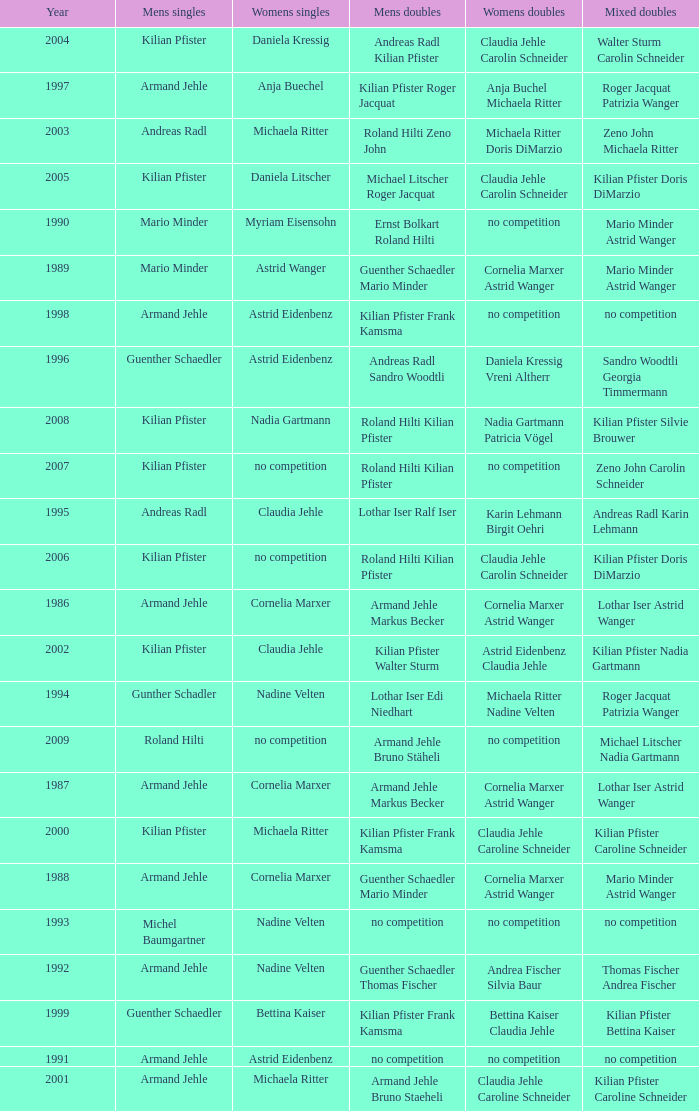In the year 2006, the womens singles had no competition and the mens doubles were roland hilti kilian pfister, what were the womens doubles Claudia Jehle Carolin Schneider. Could you parse the entire table? {'header': ['Year', 'Mens singles', 'Womens singles', 'Mens doubles', 'Womens doubles', 'Mixed doubles'], 'rows': [['2004', 'Kilian Pfister', 'Daniela Kressig', 'Andreas Radl Kilian Pfister', 'Claudia Jehle Carolin Schneider', 'Walter Sturm Carolin Schneider'], ['1997', 'Armand Jehle', 'Anja Buechel', 'Kilian Pfister Roger Jacquat', 'Anja Buchel Michaela Ritter', 'Roger Jacquat Patrizia Wanger'], ['2003', 'Andreas Radl', 'Michaela Ritter', 'Roland Hilti Zeno John', 'Michaela Ritter Doris DiMarzio', 'Zeno John Michaela Ritter'], ['2005', 'Kilian Pfister', 'Daniela Litscher', 'Michael Litscher Roger Jacquat', 'Claudia Jehle Carolin Schneider', 'Kilian Pfister Doris DiMarzio'], ['1990', 'Mario Minder', 'Myriam Eisensohn', 'Ernst Bolkart Roland Hilti', 'no competition', 'Mario Minder Astrid Wanger'], ['1989', 'Mario Minder', 'Astrid Wanger', 'Guenther Schaedler Mario Minder', 'Cornelia Marxer Astrid Wanger', 'Mario Minder Astrid Wanger'], ['1998', 'Armand Jehle', 'Astrid Eidenbenz', 'Kilian Pfister Frank Kamsma', 'no competition', 'no competition'], ['1996', 'Guenther Schaedler', 'Astrid Eidenbenz', 'Andreas Radl Sandro Woodtli', 'Daniela Kressig Vreni Altherr', 'Sandro Woodtli Georgia Timmermann'], ['2008', 'Kilian Pfister', 'Nadia Gartmann', 'Roland Hilti Kilian Pfister', 'Nadia Gartmann Patricia Vögel', 'Kilian Pfister Silvie Brouwer'], ['2007', 'Kilian Pfister', 'no competition', 'Roland Hilti Kilian Pfister', 'no competition', 'Zeno John Carolin Schneider'], ['1995', 'Andreas Radl', 'Claudia Jehle', 'Lothar Iser Ralf Iser', 'Karin Lehmann Birgit Oehri', 'Andreas Radl Karin Lehmann'], ['2006', 'Kilian Pfister', 'no competition', 'Roland Hilti Kilian Pfister', 'Claudia Jehle Carolin Schneider', 'Kilian Pfister Doris DiMarzio'], ['1986', 'Armand Jehle', 'Cornelia Marxer', 'Armand Jehle Markus Becker', 'Cornelia Marxer Astrid Wanger', 'Lothar Iser Astrid Wanger'], ['2002', 'Kilian Pfister', 'Claudia Jehle', 'Kilian Pfister Walter Sturm', 'Astrid Eidenbenz Claudia Jehle', 'Kilian Pfister Nadia Gartmann'], ['1994', 'Gunther Schadler', 'Nadine Velten', 'Lothar Iser Edi Niedhart', 'Michaela Ritter Nadine Velten', 'Roger Jacquat Patrizia Wanger'], ['2009', 'Roland Hilti', 'no competition', 'Armand Jehle Bruno Stäheli', 'no competition', 'Michael Litscher Nadia Gartmann'], ['1987', 'Armand Jehle', 'Cornelia Marxer', 'Armand Jehle Markus Becker', 'Cornelia Marxer Astrid Wanger', 'Lothar Iser Astrid Wanger'], ['2000', 'Kilian Pfister', 'Michaela Ritter', 'Kilian Pfister Frank Kamsma', 'Claudia Jehle Caroline Schneider', 'Kilian Pfister Caroline Schneider'], ['1988', 'Armand Jehle', 'Cornelia Marxer', 'Guenther Schaedler Mario Minder', 'Cornelia Marxer Astrid Wanger', 'Mario Minder Astrid Wanger'], ['1993', 'Michel Baumgartner', 'Nadine Velten', 'no competition', 'no competition', 'no competition'], ['1992', 'Armand Jehle', 'Nadine Velten', 'Guenther Schaedler Thomas Fischer', 'Andrea Fischer Silvia Baur', 'Thomas Fischer Andrea Fischer'], ['1999', 'Guenther Schaedler', 'Bettina Kaiser', 'Kilian Pfister Frank Kamsma', 'Bettina Kaiser Claudia Jehle', 'Kilian Pfister Bettina Kaiser'], ['1991', 'Armand Jehle', 'Astrid Eidenbenz', 'no competition', 'no competition', 'no competition'], ['2001', 'Armand Jehle', 'Michaela Ritter', 'Armand Jehle Bruno Staeheli', 'Claudia Jehle Caroline Schneider', 'Kilian Pfister Caroline Schneider']]} 